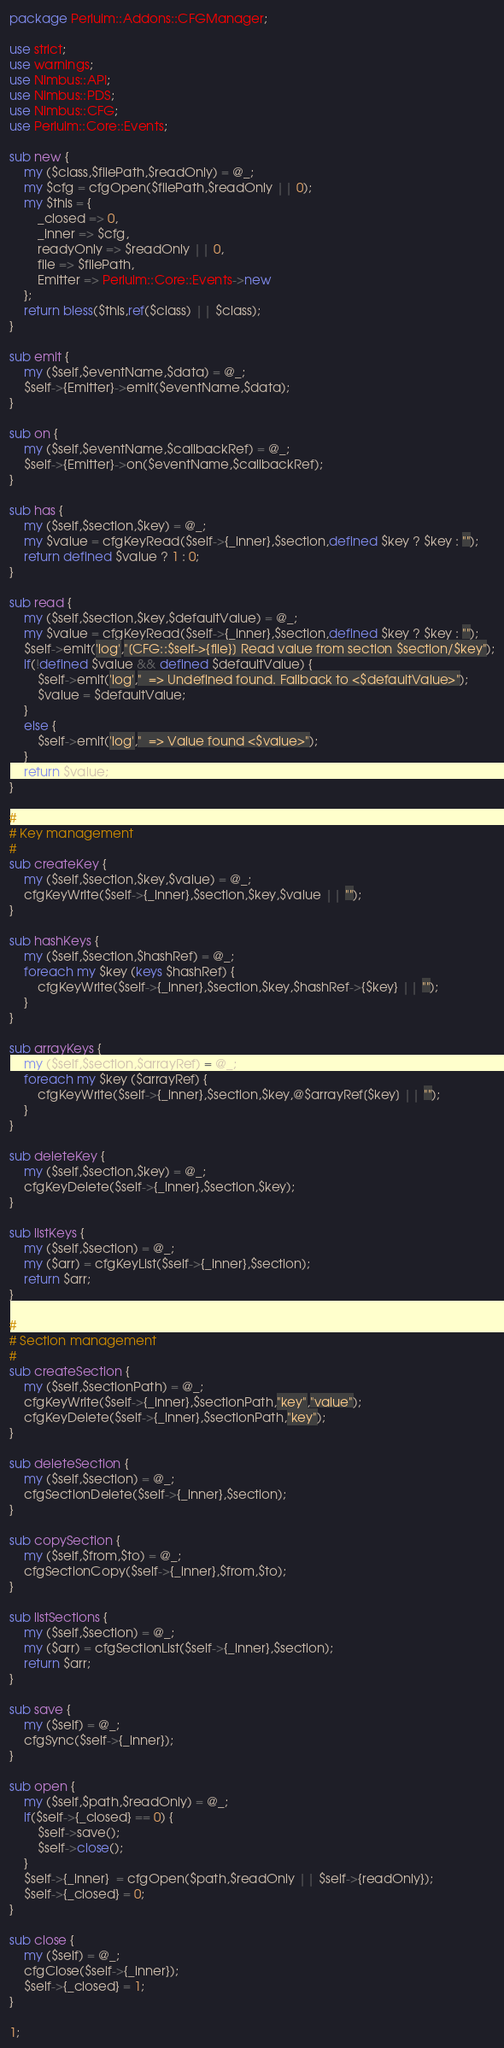<code> <loc_0><loc_0><loc_500><loc_500><_Perl_>package Perluim::Addons::CFGManager;

use strict;
use warnings;
use Nimbus::API;
use Nimbus::PDS;
use Nimbus::CFG;
use Perluim::Core::Events;

sub new {
    my ($class,$filePath,$readOnly) = @_;
    my $cfg = cfgOpen($filePath,$readOnly || 0);
    my $this = {
        _closed => 0,
        _inner => $cfg,
        readyOnly => $readOnly || 0,
        file => $filePath,
        Emitter => Perluim::Core::Events->new
    };
    return bless($this,ref($class) || $class);
}

sub emit {
    my ($self,$eventName,$data) = @_;
    $self->{Emitter}->emit($eventName,$data);
}

sub on {
    my ($self,$eventName,$callbackRef) = @_;
    $self->{Emitter}->on($eventName,$callbackRef);
}

sub has {
    my ($self,$section,$key) = @_;
    my $value = cfgKeyRead($self->{_inner},$section,defined $key ? $key : "");
    return defined $value ? 1 : 0; 
}

sub read {
    my ($self,$section,$key,$defaultValue) = @_;
    my $value = cfgKeyRead($self->{_inner},$section,defined $key ? $key : "");
    $self->emit('log',"[CFG::$self->{file}] Read value from section $section/$key");
    if(!defined $value && defined $defaultValue) {
        $self->emit('log',"  => Undefined found. Fallback to <$defaultValue>");
        $value = $defaultValue;
    }
    else {
        $self->emit('log',"  => Value found <$value>");
    }
    return $value;
}

#
# Key management
# 
sub createKey {
    my ($self,$section,$key,$value) = @_; 
    cfgKeyWrite($self->{_inner},$section,$key,$value || "");
}

sub hashKeys {
    my ($self,$section,$hashRef) = @_;
    foreach my $key (keys $hashRef) {
        cfgKeyWrite($self->{_inner},$section,$key,$hashRef->{$key} || "");
    }
}

sub arrayKeys {
    my ($self,$section,$arrayRef) = @_;
    foreach my $key ($arrayRef) {
        cfgKeyWrite($self->{_inner},$section,$key,@$arrayRef[$key] || "");
    }
}
 
sub deleteKey {
    my ($self,$section,$key) = @_;
    cfgKeyDelete($self->{_inner},$section,$key);
}

sub listKeys {
    my ($self,$section) = @_;
    my ($arr) = cfgKeyList($self->{_inner},$section);
    return $arr;
}

#
# Section management
#
sub createSection {
    my ($self,$sectionPath) = @_;
    cfgKeyWrite($self->{_inner},$sectionPath,"key","value");
    cfgKeyDelete($self->{_inner},$sectionPath,"key");
}

sub deleteSection {
    my ($self,$section) = @_;
    cfgSectionDelete($self->{_inner},$section);
}

sub copySection {
    my ($self,$from,$to) = @_; 
    cfgSectionCopy($self->{_inner},$from,$to);
}

sub listSections {
    my ($self,$section) = @_;
    my ($arr) = cfgSectionList($self->{_inner},$section);
    return $arr;
}

sub save {
    my ($self) = @_;
    cfgSync($self->{_inner});
}

sub open {
    my ($self,$path,$readOnly) = @_;
    if($self->{_closed} == 0) {
        $self->save();
        $self->close();
    }
    $self->{_inner}  = cfgOpen($path,$readOnly || $self->{readOnly});
    $self->{_closed} = 0;
}

sub close {
    my ($self) = @_;
    cfgClose($self->{_inner});
    $self->{_closed} = 1;
}

1;</code> 